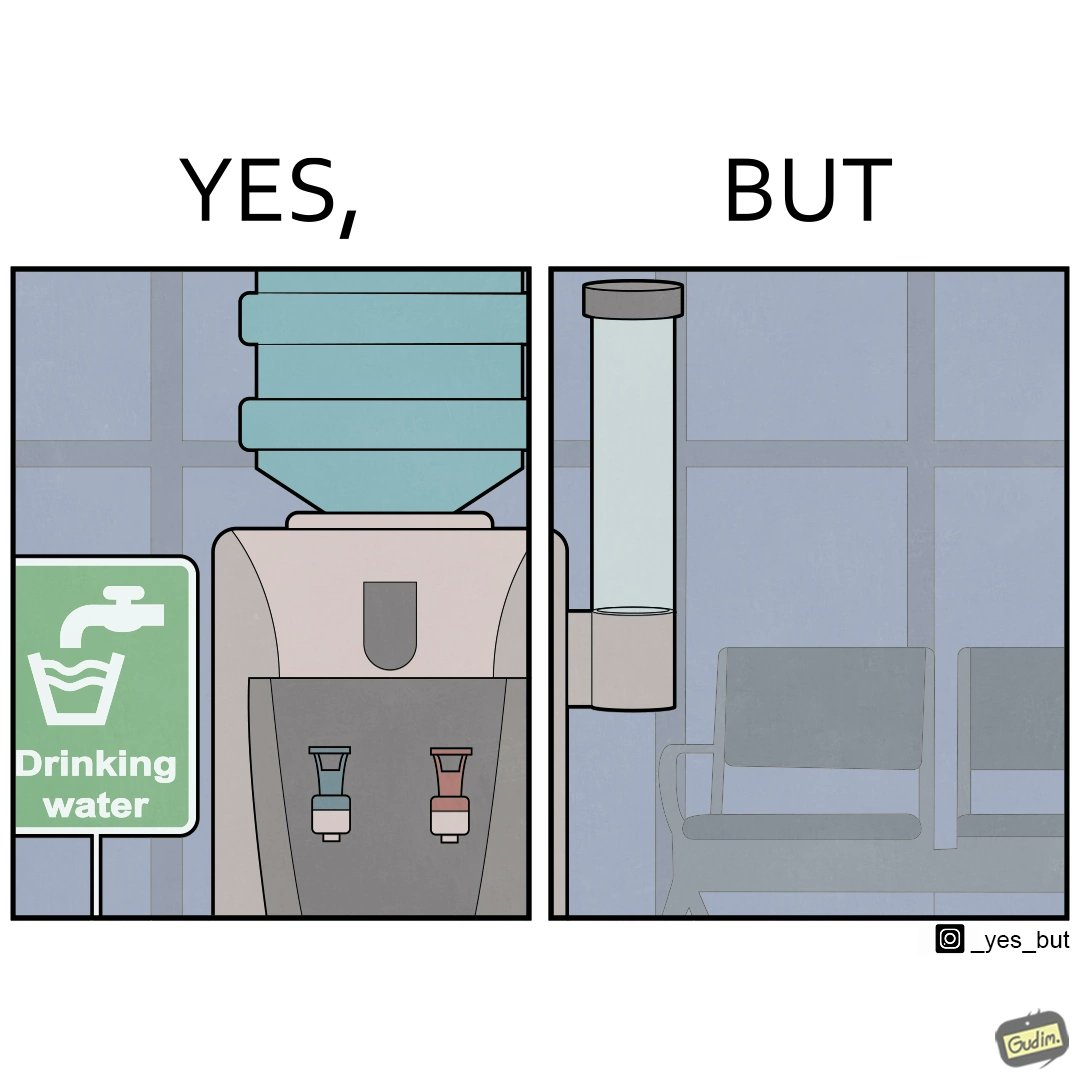Provide a description of this image. The images are funny since they show how a workspace has installed drinking water dispenser but it is of no use since the water cup dispenser is left empty 